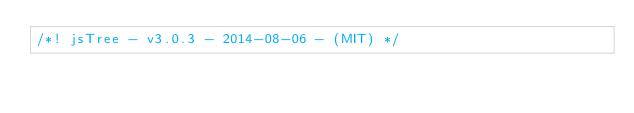<code> <loc_0><loc_0><loc_500><loc_500><_JavaScript_>/*! jsTree - v3.0.3 - 2014-08-06 - (MIT) */</code> 